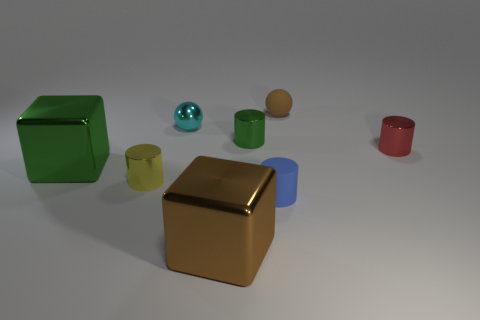Subtract all tiny green cylinders. How many cylinders are left? 3 Subtract all cyan spheres. How many spheres are left? 1 Add 2 small cyan cylinders. How many objects exist? 10 Subtract all cubes. How many objects are left? 6 Add 6 red objects. How many red objects exist? 7 Subtract 0 cyan cubes. How many objects are left? 8 Subtract 2 balls. How many balls are left? 0 Subtract all cyan balls. Subtract all red cubes. How many balls are left? 1 Subtract all matte spheres. Subtract all brown objects. How many objects are left? 5 Add 6 small brown rubber objects. How many small brown rubber objects are left? 7 